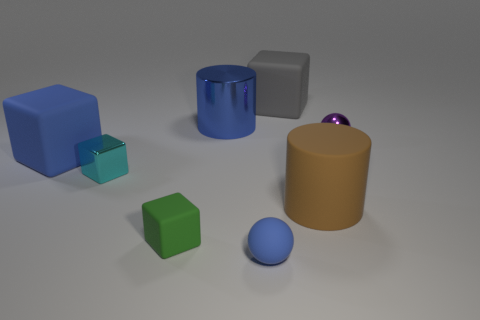There is a metal object that is in front of the purple metal thing; what number of small blue rubber spheres are in front of it?
Offer a terse response. 1. What number of things are either shiny objects to the left of the small green object or small cyan metal cubes in front of the big gray matte thing?
Provide a short and direct response. 1. There is another large thing that is the same shape as the brown thing; what is its material?
Offer a terse response. Metal. What number of things are large things that are on the right side of the big blue metallic object or balls?
Offer a very short reply. 4. The tiny blue object that is made of the same material as the brown object is what shape?
Your answer should be compact. Sphere. How many other big gray objects have the same shape as the large gray matte thing?
Offer a very short reply. 0. What is the tiny purple sphere made of?
Provide a short and direct response. Metal. Does the metallic sphere have the same color as the big thing right of the gray matte block?
Make the answer very short. No. How many spheres are gray objects or green objects?
Offer a terse response. 0. There is a tiny sphere to the right of the large gray matte cube; what color is it?
Keep it short and to the point. Purple. 